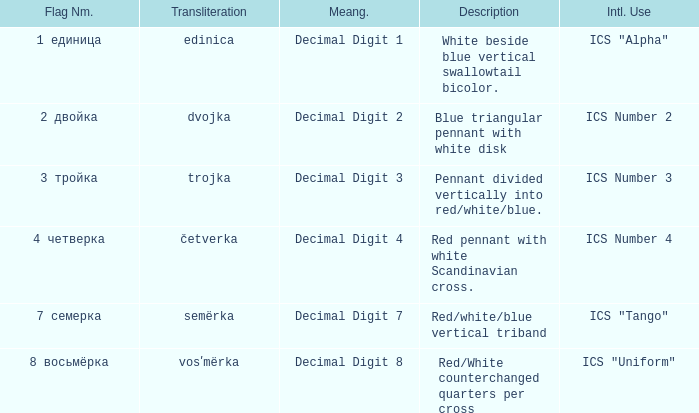What are the meanings of the flag whose name transliterates to semërka? Decimal Digit 7. 